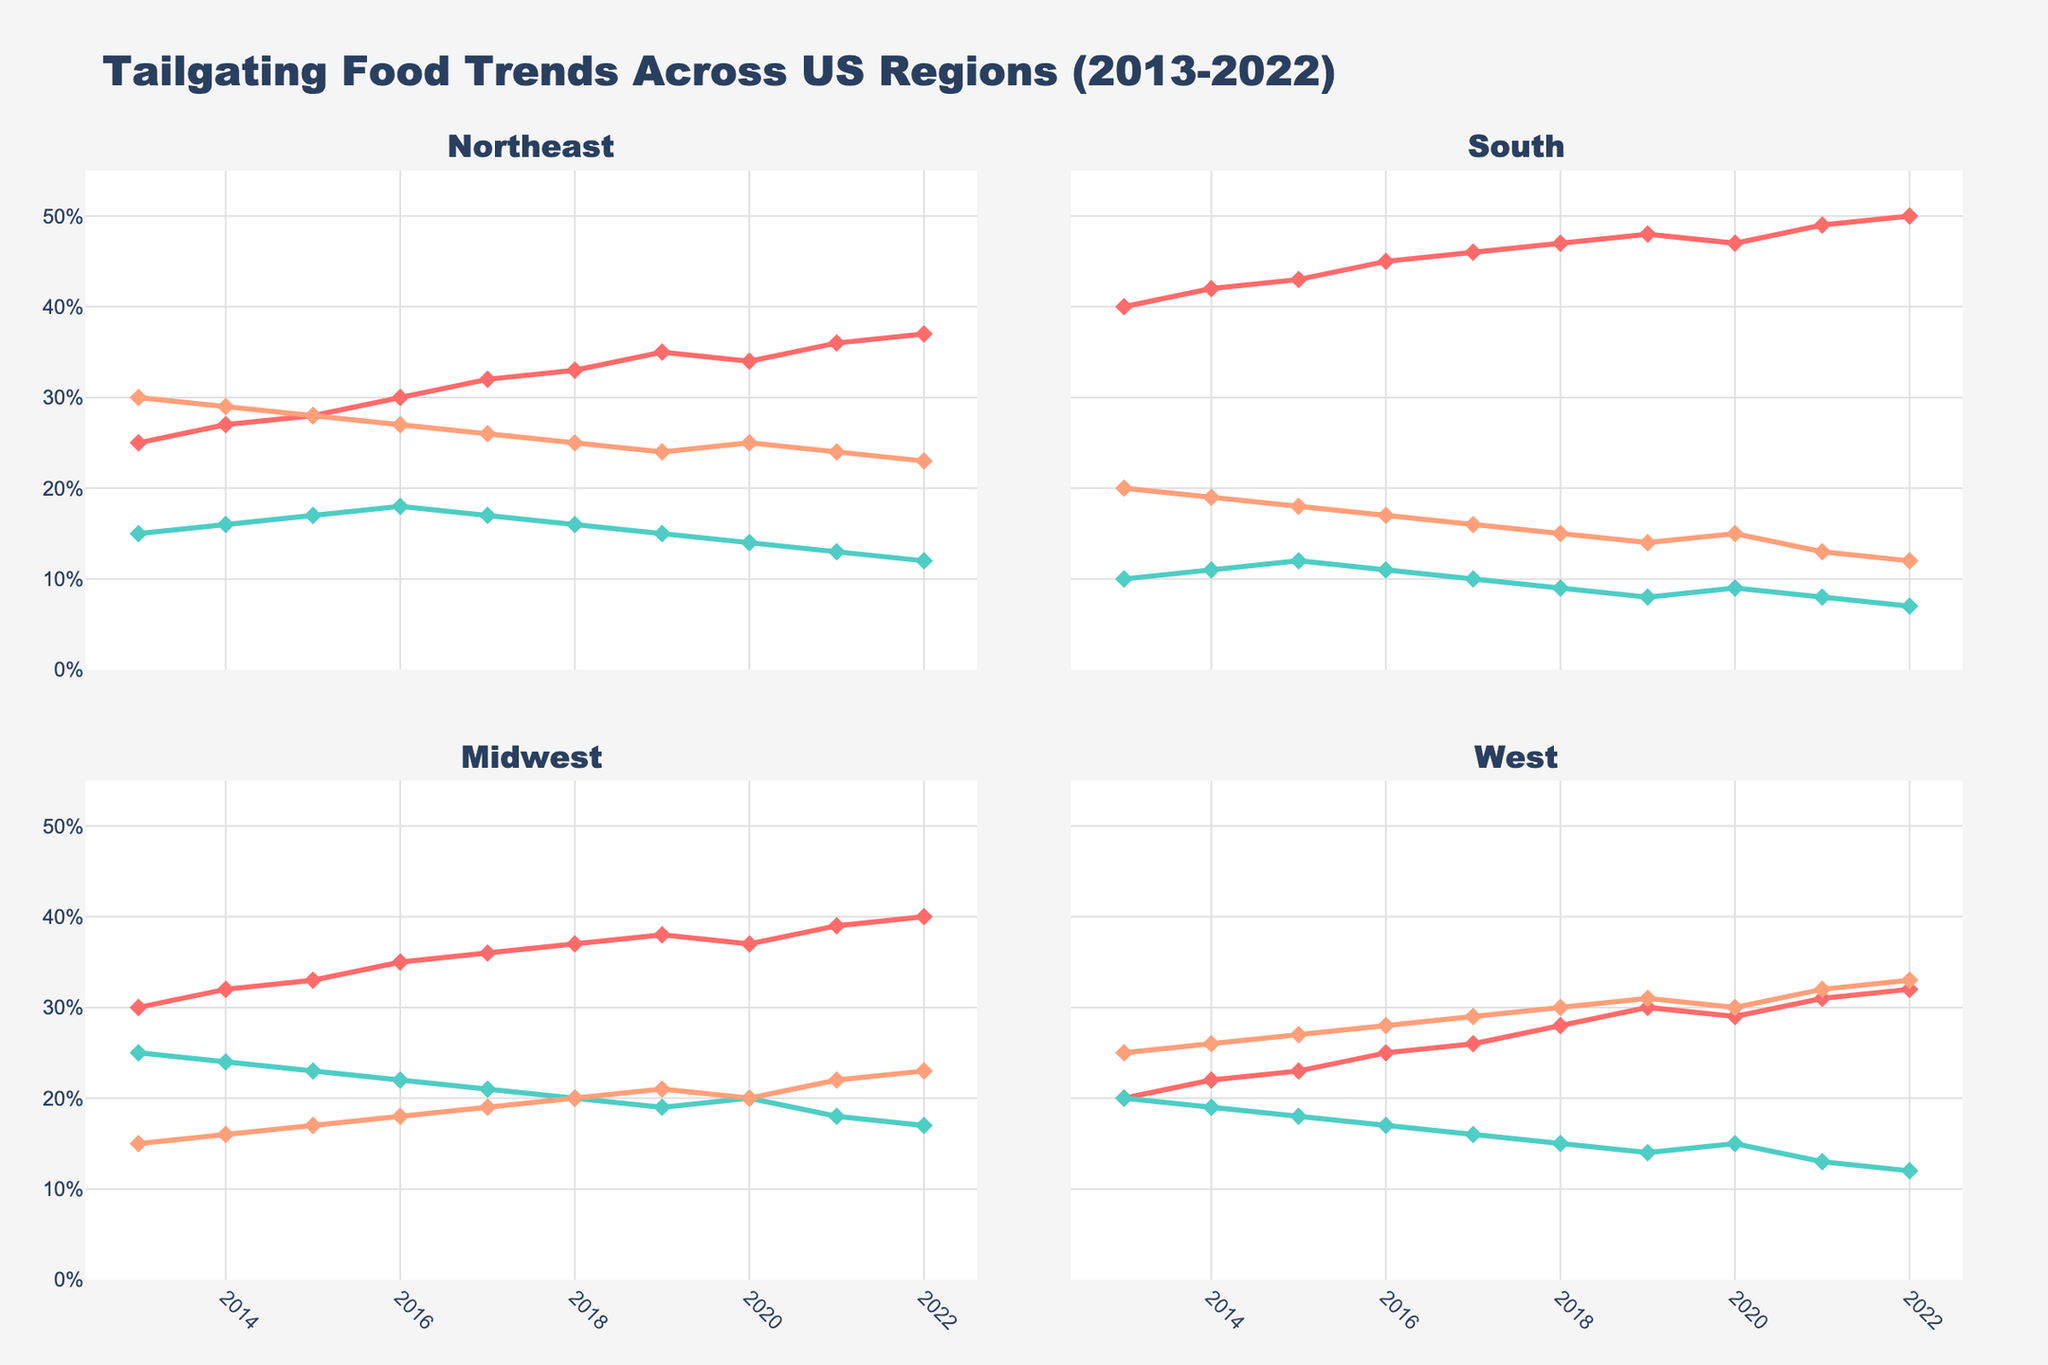What was the most popular tailgating food in the Midwest in 2022? The Midwest region is represented in one of the four subplots. By looking at the lines in that subplot for the year 2022, we see the value for BBQ is the highest among BBQ, Chili, and Wings.
Answer: BBQ How did the preference for Chili in the Northeast change from 2013 to 2022? Look at the plot for the Northeast region and compare the values for Chili in 2013 and 2022. In 2013, the preference was 15%, while in 2022, it dropped to 12%.
Answer: It decreased by 3 percentage points Which region had the highest preference for Wings in any given year during the decade? By examining all the subplots, the highest peak for Wings can be observed. The highest value is found in the West region for the year 2022 at 33%.
Answer: West Compare the trend for BBQ preferences in the South and the Midwest from 2013 to 2022. The subplot for the South and Midwest shows the trend lines for BBQ. Both regions show an increasing trend, but the South started at a higher value and ended at a higher value compared to the Midwest.
Answer: Both increased, South remained higher What is the difference in Chili preference between the Midwest and the West in 2021? Locate the 2021 values for Chili in the Midwest and West subplots. The Midwest was at 18%, and the West was at 13%. The difference is 18% - 13%.
Answer: 5 percentage points What was the average preference for Wings in the Northeast from 2013 to 2022? Sum the values for Wings in the Northeast from 2013 to 2022 (30+29+28+27+26+25+24+25+24+23) and divide by the number of years (10).
Answer: 26.1% In which year did the South have the highest preference for BBQ, and what was the value? By examining the trend line for BBQ in the South subplot, the maximum value was reached in 2022 at 50%.
Answer: 2022, 50% Which region had the least variation in Chili preferences over the decade? By comparing the Chili lines across all subplots, we see the least variation in Chili preferences happened in the South, where values stayed within a narrow range from 10% to 7%.
Answer: South Between which years did the West see the biggest increase in BBQ preference? Focus on the BBQ line in the West subplot and identify the year-to-year changes. The biggest increase occurred between 2016 and 2017 (from 25% to 26%).
Answer: 2016 to 2017 Was there any region where Wings preference declined consistently over the decade? By observing the trend lines for Wings in each subplot, all regions either had stable or increasing trends for certain periods, but the South showed a consistent decline overall, from 20% to 12%.
Answer: South 